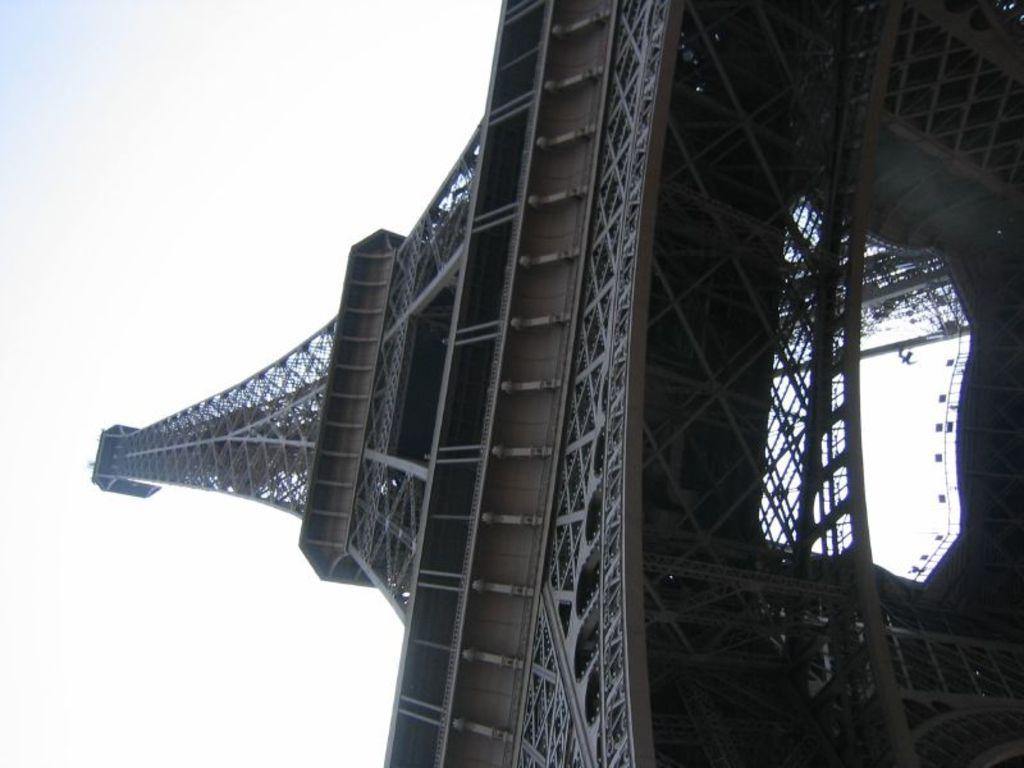Please provide a concise description of this image. In this image, I can see an Eiffel tower. This is the sky. 